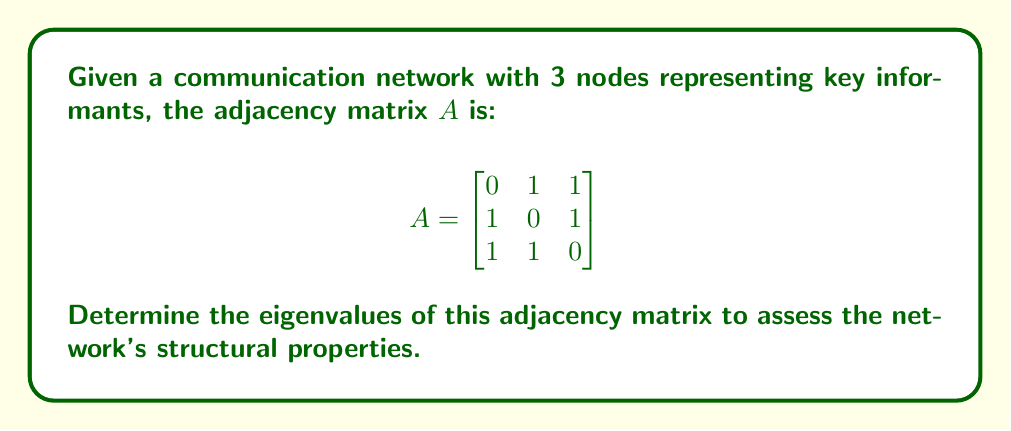Teach me how to tackle this problem. To find the eigenvalues of the adjacency matrix $A$, we need to solve the characteristic equation:

1) First, we set up the characteristic equation:
   $\det(A - \lambda I) = 0$

2) Expand the determinant:
   $$\det\begin{bmatrix}
   -\lambda & 1 & 1 \\
   1 & -\lambda & 1 \\
   1 & 1 & -\lambda
   \end{bmatrix} = 0$$

3) Calculate the determinant:
   $(-\lambda)(-\lambda)(-\lambda) + 1 \cdot 1 \cdot 1 + 1 \cdot 1 \cdot 1 - 1 \cdot (-\lambda) \cdot 1 - 1 \cdot 1 \cdot (-\lambda) - (-\lambda) \cdot 1 \cdot 1 = 0$

4) Simplify:
   $-\lambda^3 + 2 - 3\lambda = 0$

5) Rearrange to standard form:
   $\lambda^3 + 3\lambda - 2 = 0$

6) This cubic equation can be factored as:
   $(\lambda + 2)(\lambda - 1)^2 = 0$

7) Solve for $\lambda$:
   $\lambda = -2$ or $\lambda = 1$ (with algebraic multiplicity 2)

Therefore, the eigenvalues are $-2$ and $1$ (twice).
Answer: $\{-2, 1, 1\}$ 